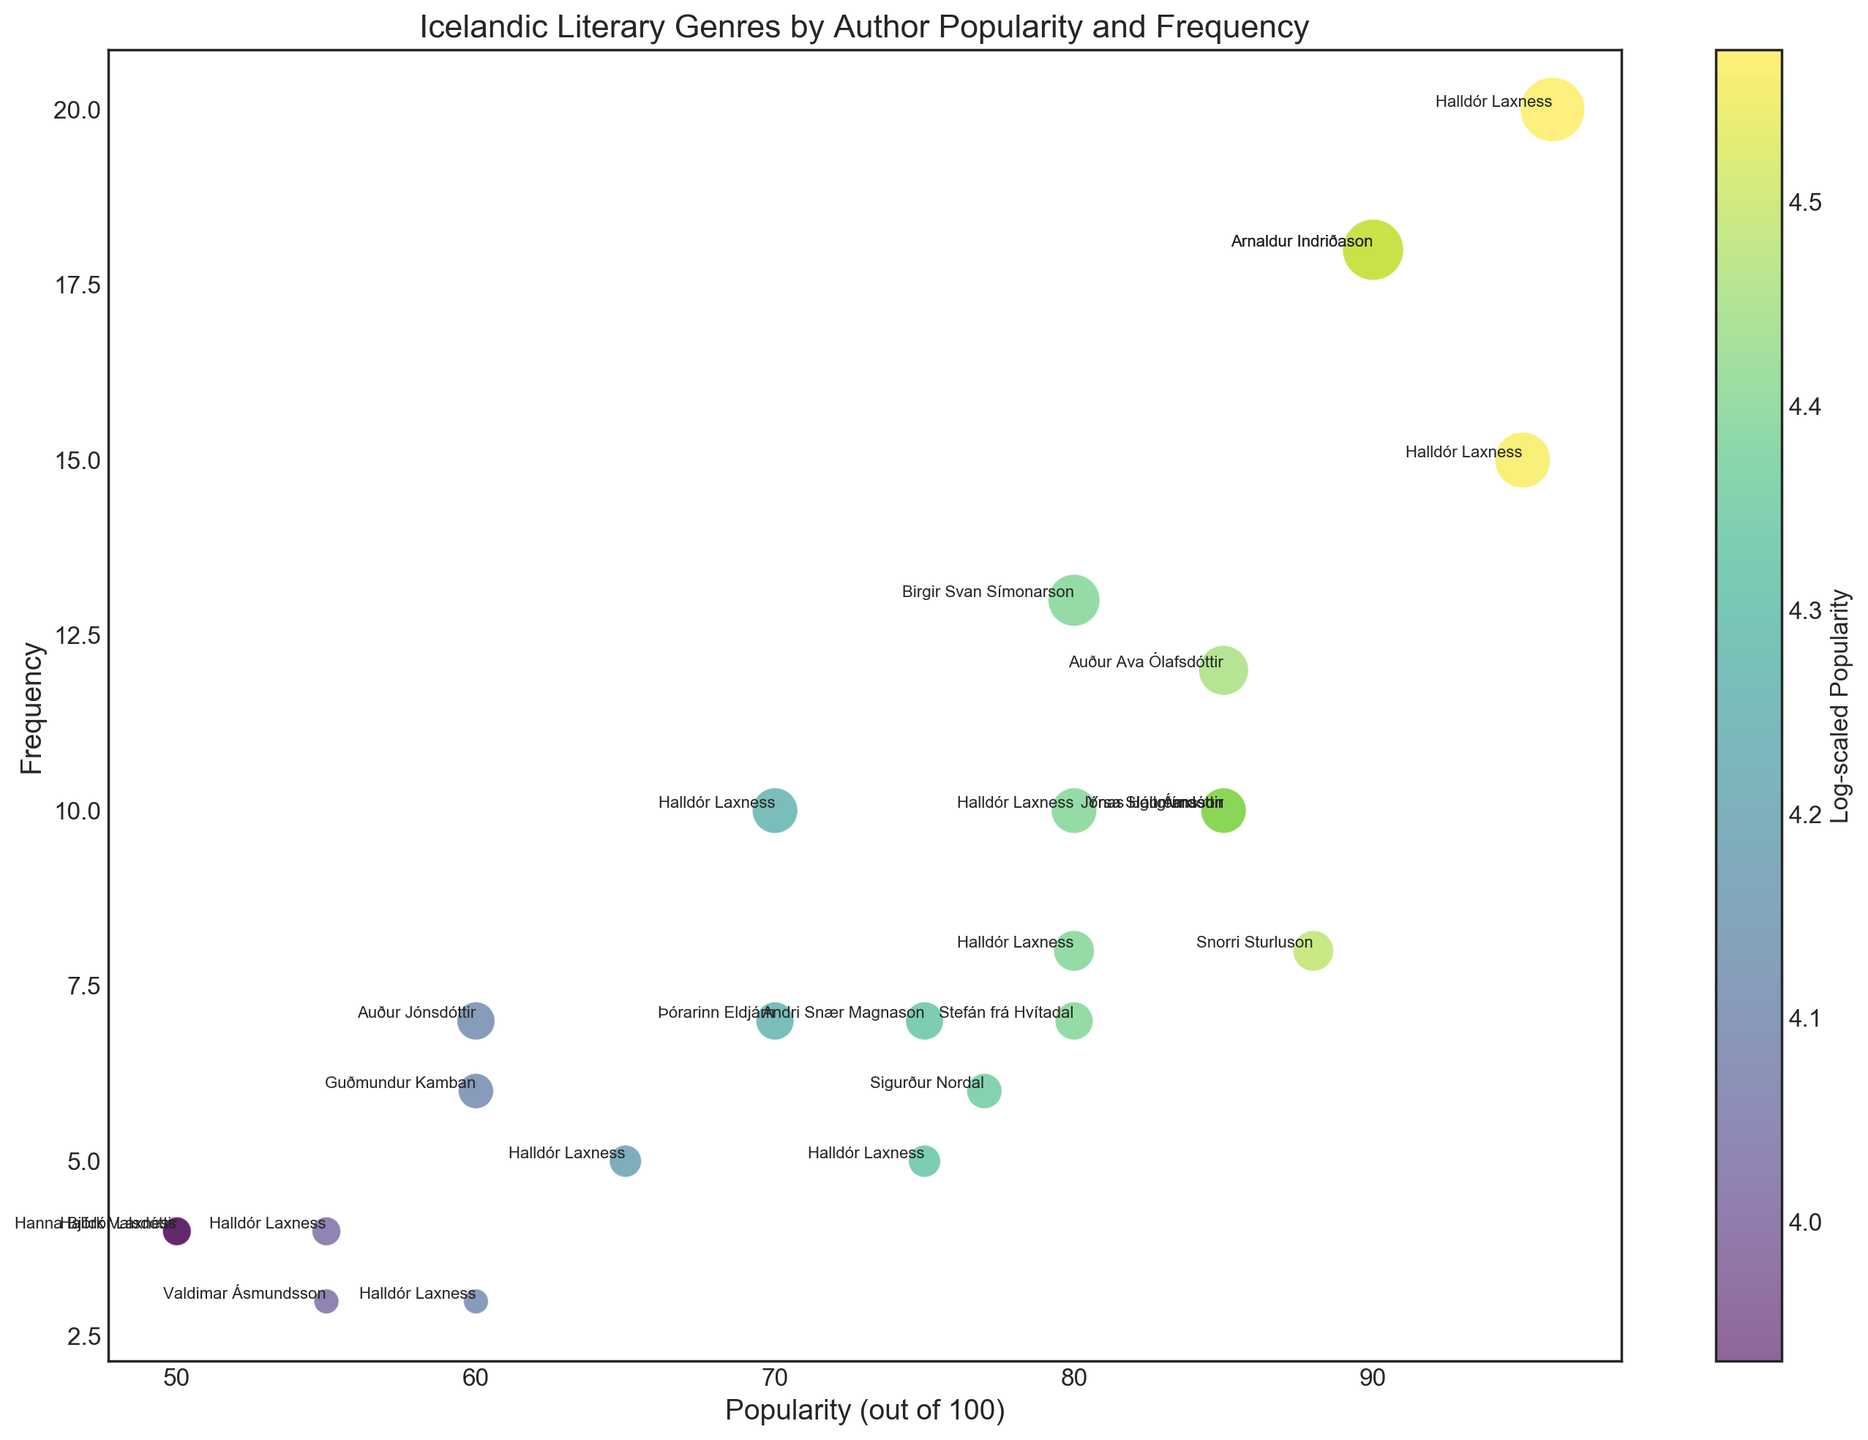What genre has Halldór Laxness written the most frequently in? Halldór Laxness has the highest frequency in novels, with a frequency of 20. This can be seen by scanning his frequencies across genres (Novels: 20, Poetry: 15, Short Stories: 10, Sagas: 5, Dramas: 4, Folklore: 3, Children's Literature: 5, Fantasy & Sci-Fi: 3, Biographies: 10, Historical Fiction: 8, Crime Fiction: 0, Romance: 4).
Answer: Novels Which genre has the highest overall frequency in the bubble chart? By evaluating the bubble sizes related to the frequency value, Novels have the highest overall frequency, with bubbles of 20 (Halldór Laxness), 18 (Arnaldur Indriðason), and 12 (Auður Ava Ólafsdóttir). Summing these frequencies results in a total frequency of 50.
Answer: Novels How does the popularity of Jón Árnason in Folklore compare to Jónas Hallgrímsson in Poetry? Jón Árnason shows a popularity value of 85 in Folklore, and Jónas Hallgrímsson shows a popularity value of 85 in Poetry. Since 85 equals 85, both authors have the same popularity in their respective genres.
Answer: equal Which author has the highest popularity in the bubble chart? The highest popularity value in the chart is 96, which belongs to Halldór Laxness in the Novels genre. This can be identified by comparing all popularity values across the data points.
Answer: Halldór Laxness What color represents the lowest popularity values, and why? The color associated with the lowest popularity values is dark green, as indicated by the color gradient on the chart's color bar. The logarithmic scaling of popularity to color emphasizes lower values in darker shades.
Answer: dark green Which genre bubbles are more transparent, and why? The transparency of the bubbles on the scatter plot indicates lower alpha, with more transparent bubbles representing less frequent or less popular categories. For example, Folklore has relatively low frequencies and appears more transparent.
Answer: Folklore Compare the frequency of Halldór Laxness' contributions to Historical Fiction and Biographies. Halldór Laxness shows a frequency of 8 in Historical Fiction and a frequency of 10 in Biographies. This indicates he has contributed more frequently to Biographies than to Historical Fiction.
Answer: Biographies Which author has the highest frequency in Children's Literature? Þórarinn Eldjárn has the highest frequency in Children's Literature with a value of 7. This can be seen by comparing his value with Halldór Laxness's frequency of 5 in the same genre.
Answer: Þórarinn Eldjárn 